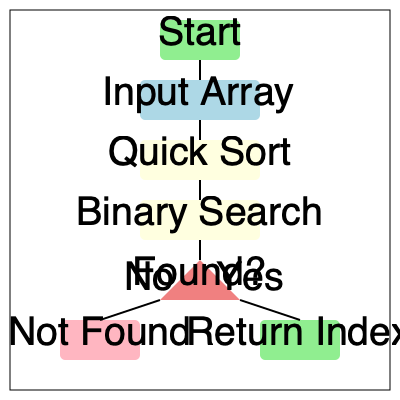In a fintech application handling large datasets of financial transactions, you need to implement a search functionality. The flowchart illustrates a process combining sorting and searching algorithms. What is the time complexity of this combined process for searching an element in an array of $n$ elements, and how does it compare to a linear search? Let's break down the process step-by-step:

1. Input Array: We start with an unsorted array of $n$ elements.

2. Quick Sort: The flowchart shows that we first apply Quick Sort to the array.
   - Quick Sort has an average-case time complexity of $O(n \log n)$.
   - In the worst case (rare), it can be $O(n^2)$, but we'll focus on the average case.

3. Binary Search: After sorting, we perform a Binary Search.
   - Binary Search has a time complexity of $O(\log n)$.

4. Combined Process:
   - Total time complexity = Time for Quick Sort + Time for Binary Search
   - $O(n \log n) + O(\log n)$
   - This simplifies to $O(n \log n)$, as the sorting dominates the complexity.

5. Comparison with Linear Search:
   - Linear Search has a time complexity of $O(n)$.
   - For a single search operation:
     - Our process: $O(n \log n)$
     - Linear Search: $O(n)$
   - Linear Search is faster for a single search operation.

6. Multiple Searches:
   - If we need to perform $k$ searches:
     - Our process: $O(n \log n)$ (sort once) + $k * O(\log n)$ (each search)
     - Linear Search: $k * O(n)$
   - Our process becomes more efficient when $k > \frac{n}{\log n}$

In the context of a fintech application dealing with large datasets:
- If searches are infrequent, Linear Search might be sufficient.
- If multiple searches are performed on the same dataset, the sorting + binary search approach becomes more efficient.
- The sorted array also allows for other efficient operations like finding ranges of values quickly.
Answer: $O(n \log n)$; slower than linear search for single operations, faster for multiple searches when $k > \frac{n}{\log n}$. 